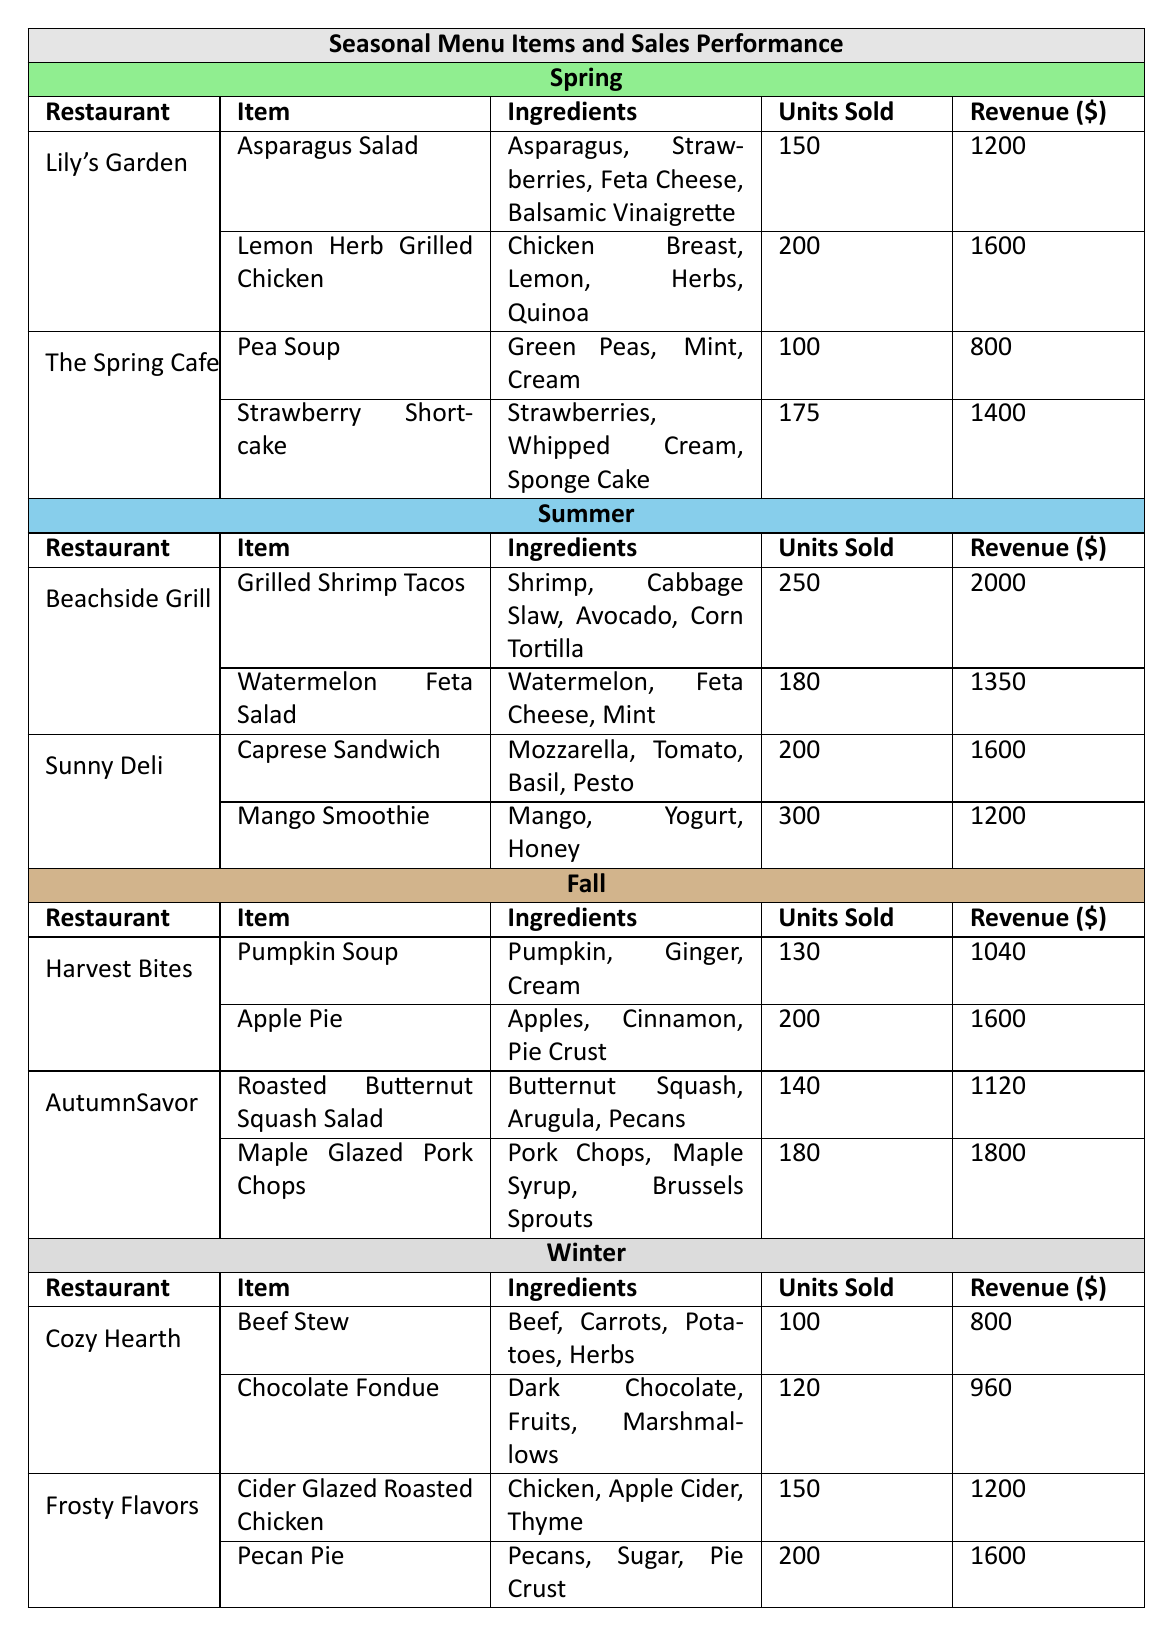What is the item with the highest revenue in Spring? Looking at the Spring section, the item with the highest revenue is the "Lemon Herb Grilled Chicken" with a revenue of $1600.
Answer: Lemon Herb Grilled Chicken How many units of the "Mango Smoothie" were sold? In the Summer section, looking at the "Sunny Deli", the "Mango Smoothie" had 300 units sold.
Answer: 300 Which fall item sold the least number of units? In Fall, "Pumpkin Soup" sold 130 units, which is less than "Apple Pie" (200 units) and the other Fall items.
Answer: Pumpkin Soup What was the total revenue generated from menu items in Winter? The total revenue for Winter comes from "Cozy Hearth" ($800 + $960) and "Frosty Flavors" ($1200 + $1600), giving a total of $800 + $960 + $1200 + $1600 = $3560.
Answer: $3560 Is "Strawberry Shortcake" offered in Fall? "Strawberry Shortcake" is part of the Spring menu, not Fall, so this statement is false.
Answer: No Which restaurant had the highest total sales in Summer? "Sunny Deli" had a total of 200 units (Caprese Sandwich) + 300 units (Mango Smoothie) = 500 units, which is higher than "Beachside Grill" with 250 + 180 = 430.
Answer: Sunny Deli What is the average revenue of menu items offered in Spring? For Spring, total revenue is $1200 (Asparagus Salad) + $1600 (Lemon Herb Grilled Chicken) + $800 (Pea Soup) + $1400 (Strawberry Shortcake) = $4000. Dividing this by 4 gives an average of $1000.
Answer: $1000 What seasonal menu item had the same number of units sold as the revenue of the item in fall? "Apple Pie" in Fall had 200 units sold and generated $1600, matching the "Pecan Pie" revenue from Winter which also generated $1600 and had 200 units sold.
Answer: Pecan Pie Which season has the item with the maximum units sold? In Summer, "Mango Smoothie" sold 300 units, which is the highest among all seasons' items; no item in other seasons exceeds this amount.
Answer: Summer How many more units were sold of the "Pecan Pie" than the "Beef Stew"? "Pecan Pie" had 200 units sold and "Beef Stew" had 100 units sold. The difference is 200 - 100 = 100.
Answer: 100 